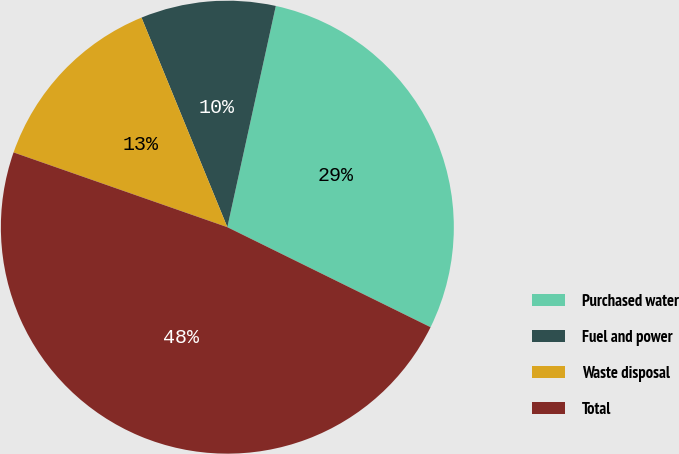<chart> <loc_0><loc_0><loc_500><loc_500><pie_chart><fcel>Purchased water<fcel>Fuel and power<fcel>Waste disposal<fcel>Total<nl><fcel>28.85%<fcel>9.62%<fcel>13.46%<fcel>48.08%<nl></chart> 